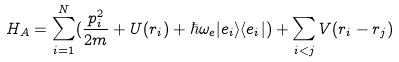<formula> <loc_0><loc_0><loc_500><loc_500>H _ { A } = \sum _ { i = 1 } ^ { N } ( \frac { p _ { i } ^ { 2 } } { 2 m } + U ( r _ { i } ) + \hbar { \omega } _ { e } | e _ { i } \rangle \langle e _ { i } | ) + \sum _ { i < j } V ( r _ { i } - r _ { j } )</formula> 